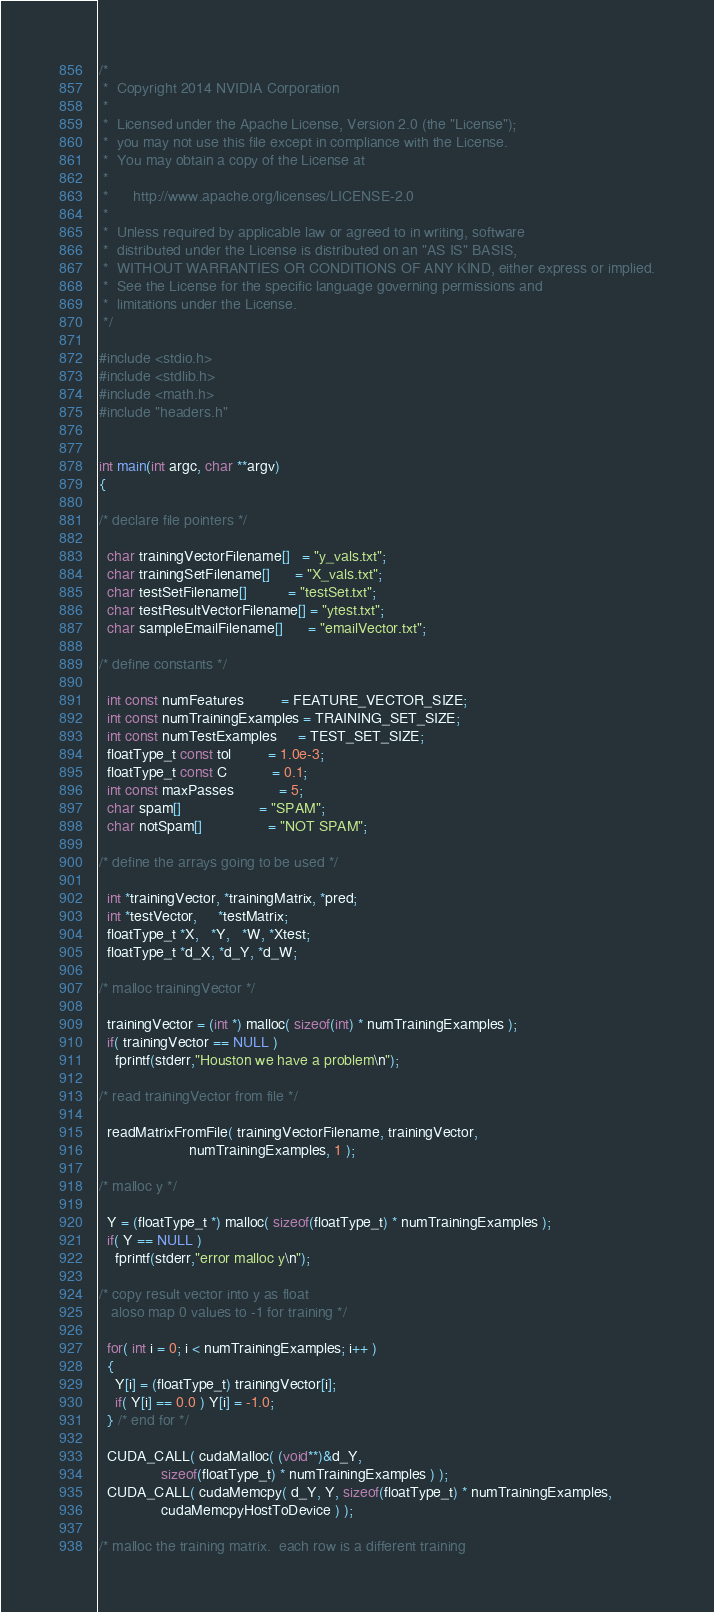Convert code to text. <code><loc_0><loc_0><loc_500><loc_500><_Cuda_>/*
 *  Copyright 2014 NVIDIA Corporation
 *
 *  Licensed under the Apache License, Version 2.0 (the "License");
 *  you may not use this file except in compliance with the License.
 *  You may obtain a copy of the License at
 *
 *      http://www.apache.org/licenses/LICENSE-2.0
 *
 *  Unless required by applicable law or agreed to in writing, software
 *  distributed under the License is distributed on an "AS IS" BASIS,
 *  WITHOUT WARRANTIES OR CONDITIONS OF ANY KIND, either express or implied.
 *  See the License for the specific language governing permissions and
 *  limitations under the License.
 */

#include <stdio.h>
#include <stdlib.h>
#include <math.h>
#include "headers.h"


int main(int argc, char **argv) 
{

/* declare file pointers */

  char trainingVectorFilename[]   = "y_vals.txt";
  char trainingSetFilename[]      = "X_vals.txt";
  char testSetFilename[]          = "testSet.txt";
  char testResultVectorFilename[] = "ytest.txt";
  char sampleEmailFilename[]      = "emailVector.txt";

/* define constants */

  int const numFeatures         = FEATURE_VECTOR_SIZE;
  int const numTrainingExamples = TRAINING_SET_SIZE;
  int const numTestExamples     = TEST_SET_SIZE;
  floatType_t const tol         = 1.0e-3;
  floatType_t const C           = 0.1;
  int const maxPasses           = 5;
  char spam[]                   = "SPAM";
  char notSpam[]                = "NOT SPAM";

/* define the arrays going to be used */

  int *trainingVector, *trainingMatrix, *pred;
  int *testVector,     *testMatrix;
  floatType_t *X,   *Y,   *W, *Xtest;
  floatType_t *d_X, *d_Y, *d_W;

/* malloc trainingVector */

  trainingVector = (int *) malloc( sizeof(int) * numTrainingExamples );
  if( trainingVector == NULL ) 
    fprintf(stderr,"Houston we have a problem\n");

/* read trainingVector from file */
 
  readMatrixFromFile( trainingVectorFilename, trainingVector, 
                      numTrainingExamples, 1 );

/* malloc y */

  Y = (floatType_t *) malloc( sizeof(floatType_t) * numTrainingExamples );
  if( Y == NULL ) 
    fprintf(stderr,"error malloc y\n");

/* copy result vector into y as float 
   aloso map 0 values to -1 for training */

  for( int i = 0; i < numTrainingExamples; i++ ) 
  {
    Y[i] = (floatType_t) trainingVector[i];
    if( Y[i] == 0.0 ) Y[i] = -1.0;
  } /* end for */

  CUDA_CALL( cudaMalloc( (void**)&d_Y, 
               sizeof(floatType_t) * numTrainingExamples ) );
  CUDA_CALL( cudaMemcpy( d_Y, Y, sizeof(floatType_t) * numTrainingExamples, 
               cudaMemcpyHostToDevice ) );

/* malloc the training matrix.  each row is a different training</code> 